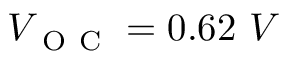Convert formula to latex. <formula><loc_0><loc_0><loc_500><loc_500>V _ { O C } = 0 . 6 2 \ V</formula> 